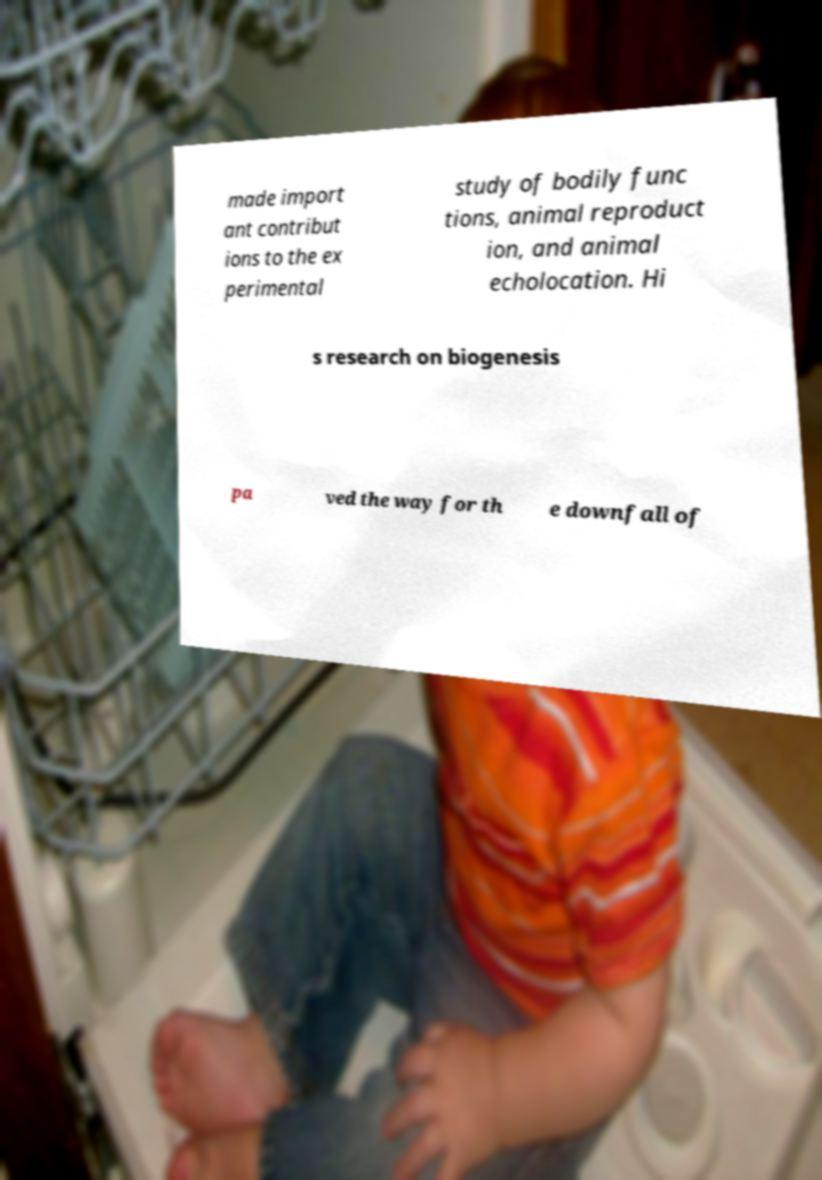Could you extract and type out the text from this image? made import ant contribut ions to the ex perimental study of bodily func tions, animal reproduct ion, and animal echolocation. Hi s research on biogenesis pa ved the way for th e downfall of 